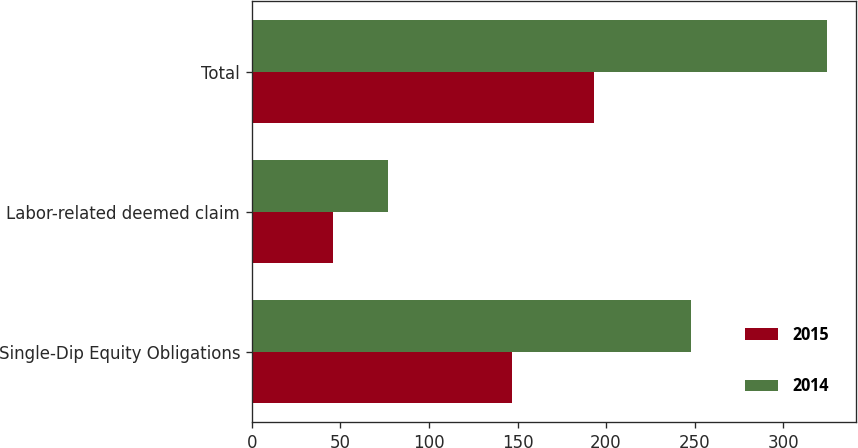<chart> <loc_0><loc_0><loc_500><loc_500><stacked_bar_chart><ecel><fcel>Single-Dip Equity Obligations<fcel>Labor-related deemed claim<fcel>Total<nl><fcel>2015<fcel>147<fcel>46<fcel>193<nl><fcel>2014<fcel>248<fcel>77<fcel>325<nl></chart> 